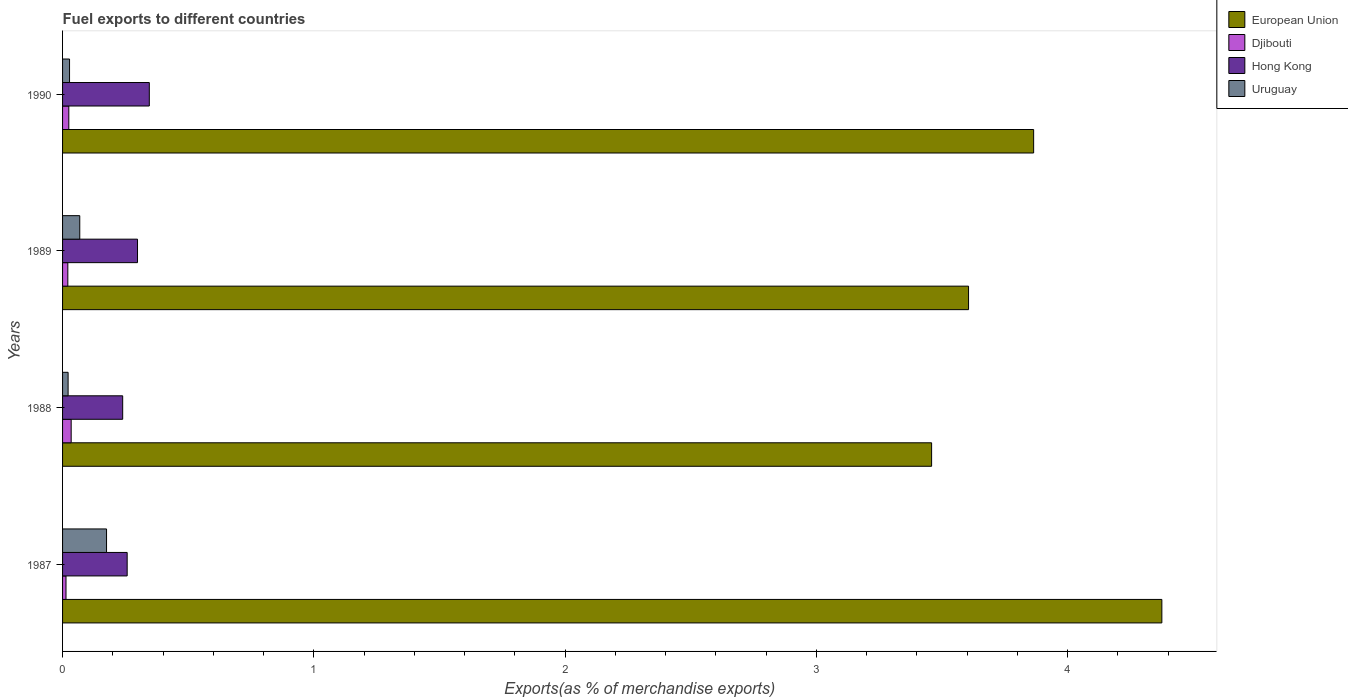How many different coloured bars are there?
Give a very brief answer. 4. Are the number of bars per tick equal to the number of legend labels?
Your answer should be very brief. Yes. Are the number of bars on each tick of the Y-axis equal?
Keep it short and to the point. Yes. How many bars are there on the 2nd tick from the top?
Provide a succinct answer. 4. What is the label of the 1st group of bars from the top?
Make the answer very short. 1990. In how many cases, is the number of bars for a given year not equal to the number of legend labels?
Your response must be concise. 0. What is the percentage of exports to different countries in Djibouti in 1987?
Offer a terse response. 0.01. Across all years, what is the maximum percentage of exports to different countries in Hong Kong?
Offer a very short reply. 0.35. Across all years, what is the minimum percentage of exports to different countries in European Union?
Offer a very short reply. 3.46. What is the total percentage of exports to different countries in Djibouti in the graph?
Provide a short and direct response. 0.09. What is the difference between the percentage of exports to different countries in European Union in 1987 and that in 1989?
Provide a short and direct response. 0.77. What is the difference between the percentage of exports to different countries in European Union in 1988 and the percentage of exports to different countries in Hong Kong in 1989?
Keep it short and to the point. 3.16. What is the average percentage of exports to different countries in European Union per year?
Give a very brief answer. 3.83. In the year 1987, what is the difference between the percentage of exports to different countries in Uruguay and percentage of exports to different countries in Hong Kong?
Provide a short and direct response. -0.08. In how many years, is the percentage of exports to different countries in European Union greater than 1.4 %?
Provide a succinct answer. 4. What is the ratio of the percentage of exports to different countries in Hong Kong in 1987 to that in 1988?
Provide a short and direct response. 1.07. What is the difference between the highest and the second highest percentage of exports to different countries in Djibouti?
Ensure brevity in your answer.  0.01. What is the difference between the highest and the lowest percentage of exports to different countries in Hong Kong?
Make the answer very short. 0.11. In how many years, is the percentage of exports to different countries in European Union greater than the average percentage of exports to different countries in European Union taken over all years?
Offer a terse response. 2. Is the sum of the percentage of exports to different countries in Djibouti in 1988 and 1989 greater than the maximum percentage of exports to different countries in Uruguay across all years?
Offer a terse response. No. Is it the case that in every year, the sum of the percentage of exports to different countries in Djibouti and percentage of exports to different countries in Uruguay is greater than the sum of percentage of exports to different countries in Hong Kong and percentage of exports to different countries in European Union?
Ensure brevity in your answer.  No. What does the 3rd bar from the bottom in 1987 represents?
Offer a terse response. Hong Kong. Is it the case that in every year, the sum of the percentage of exports to different countries in Uruguay and percentage of exports to different countries in Djibouti is greater than the percentage of exports to different countries in European Union?
Offer a terse response. No. How many years are there in the graph?
Make the answer very short. 4. Does the graph contain grids?
Ensure brevity in your answer.  No. How many legend labels are there?
Provide a succinct answer. 4. What is the title of the graph?
Your answer should be very brief. Fuel exports to different countries. Does "Low & middle income" appear as one of the legend labels in the graph?
Offer a very short reply. No. What is the label or title of the X-axis?
Offer a terse response. Exports(as % of merchandise exports). What is the Exports(as % of merchandise exports) of European Union in 1987?
Make the answer very short. 4.38. What is the Exports(as % of merchandise exports) of Djibouti in 1987?
Offer a very short reply. 0.01. What is the Exports(as % of merchandise exports) in Hong Kong in 1987?
Ensure brevity in your answer.  0.26. What is the Exports(as % of merchandise exports) in Uruguay in 1987?
Offer a terse response. 0.18. What is the Exports(as % of merchandise exports) in European Union in 1988?
Offer a terse response. 3.46. What is the Exports(as % of merchandise exports) in Djibouti in 1988?
Provide a succinct answer. 0.03. What is the Exports(as % of merchandise exports) in Hong Kong in 1988?
Your response must be concise. 0.24. What is the Exports(as % of merchandise exports) in Uruguay in 1988?
Your answer should be very brief. 0.02. What is the Exports(as % of merchandise exports) of European Union in 1989?
Ensure brevity in your answer.  3.61. What is the Exports(as % of merchandise exports) in Djibouti in 1989?
Provide a succinct answer. 0.02. What is the Exports(as % of merchandise exports) in Hong Kong in 1989?
Provide a succinct answer. 0.3. What is the Exports(as % of merchandise exports) in Uruguay in 1989?
Your answer should be compact. 0.07. What is the Exports(as % of merchandise exports) of European Union in 1990?
Offer a terse response. 3.87. What is the Exports(as % of merchandise exports) of Djibouti in 1990?
Give a very brief answer. 0.02. What is the Exports(as % of merchandise exports) of Hong Kong in 1990?
Provide a succinct answer. 0.35. What is the Exports(as % of merchandise exports) of Uruguay in 1990?
Make the answer very short. 0.03. Across all years, what is the maximum Exports(as % of merchandise exports) of European Union?
Provide a short and direct response. 4.38. Across all years, what is the maximum Exports(as % of merchandise exports) in Djibouti?
Keep it short and to the point. 0.03. Across all years, what is the maximum Exports(as % of merchandise exports) of Hong Kong?
Keep it short and to the point. 0.35. Across all years, what is the maximum Exports(as % of merchandise exports) in Uruguay?
Keep it short and to the point. 0.18. Across all years, what is the minimum Exports(as % of merchandise exports) of European Union?
Give a very brief answer. 3.46. Across all years, what is the minimum Exports(as % of merchandise exports) in Djibouti?
Give a very brief answer. 0.01. Across all years, what is the minimum Exports(as % of merchandise exports) of Hong Kong?
Your answer should be compact. 0.24. Across all years, what is the minimum Exports(as % of merchandise exports) of Uruguay?
Make the answer very short. 0.02. What is the total Exports(as % of merchandise exports) in European Union in the graph?
Your response must be concise. 15.31. What is the total Exports(as % of merchandise exports) in Djibouti in the graph?
Your answer should be compact. 0.09. What is the total Exports(as % of merchandise exports) of Hong Kong in the graph?
Your response must be concise. 1.14. What is the total Exports(as % of merchandise exports) in Uruguay in the graph?
Keep it short and to the point. 0.29. What is the difference between the Exports(as % of merchandise exports) in European Union in 1987 and that in 1988?
Your answer should be very brief. 0.92. What is the difference between the Exports(as % of merchandise exports) in Djibouti in 1987 and that in 1988?
Give a very brief answer. -0.02. What is the difference between the Exports(as % of merchandise exports) of Hong Kong in 1987 and that in 1988?
Give a very brief answer. 0.02. What is the difference between the Exports(as % of merchandise exports) of Uruguay in 1987 and that in 1988?
Keep it short and to the point. 0.15. What is the difference between the Exports(as % of merchandise exports) in European Union in 1987 and that in 1989?
Your answer should be very brief. 0.77. What is the difference between the Exports(as % of merchandise exports) in Djibouti in 1987 and that in 1989?
Keep it short and to the point. -0.01. What is the difference between the Exports(as % of merchandise exports) of Hong Kong in 1987 and that in 1989?
Your response must be concise. -0.04. What is the difference between the Exports(as % of merchandise exports) of Uruguay in 1987 and that in 1989?
Ensure brevity in your answer.  0.11. What is the difference between the Exports(as % of merchandise exports) in European Union in 1987 and that in 1990?
Your response must be concise. 0.51. What is the difference between the Exports(as % of merchandise exports) of Djibouti in 1987 and that in 1990?
Provide a short and direct response. -0.01. What is the difference between the Exports(as % of merchandise exports) of Hong Kong in 1987 and that in 1990?
Keep it short and to the point. -0.09. What is the difference between the Exports(as % of merchandise exports) in Uruguay in 1987 and that in 1990?
Offer a very short reply. 0.15. What is the difference between the Exports(as % of merchandise exports) in European Union in 1988 and that in 1989?
Your response must be concise. -0.15. What is the difference between the Exports(as % of merchandise exports) in Djibouti in 1988 and that in 1989?
Offer a very short reply. 0.01. What is the difference between the Exports(as % of merchandise exports) in Hong Kong in 1988 and that in 1989?
Provide a short and direct response. -0.06. What is the difference between the Exports(as % of merchandise exports) in Uruguay in 1988 and that in 1989?
Keep it short and to the point. -0.05. What is the difference between the Exports(as % of merchandise exports) in European Union in 1988 and that in 1990?
Offer a terse response. -0.41. What is the difference between the Exports(as % of merchandise exports) of Djibouti in 1988 and that in 1990?
Offer a very short reply. 0.01. What is the difference between the Exports(as % of merchandise exports) of Hong Kong in 1988 and that in 1990?
Give a very brief answer. -0.11. What is the difference between the Exports(as % of merchandise exports) of Uruguay in 1988 and that in 1990?
Offer a very short reply. -0.01. What is the difference between the Exports(as % of merchandise exports) of European Union in 1989 and that in 1990?
Your answer should be compact. -0.26. What is the difference between the Exports(as % of merchandise exports) in Djibouti in 1989 and that in 1990?
Ensure brevity in your answer.  -0. What is the difference between the Exports(as % of merchandise exports) in Hong Kong in 1989 and that in 1990?
Provide a short and direct response. -0.05. What is the difference between the Exports(as % of merchandise exports) in Uruguay in 1989 and that in 1990?
Offer a terse response. 0.04. What is the difference between the Exports(as % of merchandise exports) of European Union in 1987 and the Exports(as % of merchandise exports) of Djibouti in 1988?
Keep it short and to the point. 4.34. What is the difference between the Exports(as % of merchandise exports) in European Union in 1987 and the Exports(as % of merchandise exports) in Hong Kong in 1988?
Provide a succinct answer. 4.14. What is the difference between the Exports(as % of merchandise exports) in European Union in 1987 and the Exports(as % of merchandise exports) in Uruguay in 1988?
Your response must be concise. 4.35. What is the difference between the Exports(as % of merchandise exports) in Djibouti in 1987 and the Exports(as % of merchandise exports) in Hong Kong in 1988?
Provide a succinct answer. -0.23. What is the difference between the Exports(as % of merchandise exports) of Djibouti in 1987 and the Exports(as % of merchandise exports) of Uruguay in 1988?
Provide a succinct answer. -0.01. What is the difference between the Exports(as % of merchandise exports) of Hong Kong in 1987 and the Exports(as % of merchandise exports) of Uruguay in 1988?
Offer a terse response. 0.24. What is the difference between the Exports(as % of merchandise exports) in European Union in 1987 and the Exports(as % of merchandise exports) in Djibouti in 1989?
Offer a terse response. 4.35. What is the difference between the Exports(as % of merchandise exports) in European Union in 1987 and the Exports(as % of merchandise exports) in Hong Kong in 1989?
Offer a terse response. 4.08. What is the difference between the Exports(as % of merchandise exports) of European Union in 1987 and the Exports(as % of merchandise exports) of Uruguay in 1989?
Your answer should be compact. 4.31. What is the difference between the Exports(as % of merchandise exports) of Djibouti in 1987 and the Exports(as % of merchandise exports) of Hong Kong in 1989?
Your answer should be compact. -0.28. What is the difference between the Exports(as % of merchandise exports) of Djibouti in 1987 and the Exports(as % of merchandise exports) of Uruguay in 1989?
Make the answer very short. -0.05. What is the difference between the Exports(as % of merchandise exports) of Hong Kong in 1987 and the Exports(as % of merchandise exports) of Uruguay in 1989?
Give a very brief answer. 0.19. What is the difference between the Exports(as % of merchandise exports) of European Union in 1987 and the Exports(as % of merchandise exports) of Djibouti in 1990?
Ensure brevity in your answer.  4.35. What is the difference between the Exports(as % of merchandise exports) of European Union in 1987 and the Exports(as % of merchandise exports) of Hong Kong in 1990?
Provide a succinct answer. 4.03. What is the difference between the Exports(as % of merchandise exports) of European Union in 1987 and the Exports(as % of merchandise exports) of Uruguay in 1990?
Give a very brief answer. 4.35. What is the difference between the Exports(as % of merchandise exports) in Djibouti in 1987 and the Exports(as % of merchandise exports) in Hong Kong in 1990?
Provide a succinct answer. -0.33. What is the difference between the Exports(as % of merchandise exports) of Djibouti in 1987 and the Exports(as % of merchandise exports) of Uruguay in 1990?
Provide a succinct answer. -0.01. What is the difference between the Exports(as % of merchandise exports) of Hong Kong in 1987 and the Exports(as % of merchandise exports) of Uruguay in 1990?
Offer a terse response. 0.23. What is the difference between the Exports(as % of merchandise exports) of European Union in 1988 and the Exports(as % of merchandise exports) of Djibouti in 1989?
Make the answer very short. 3.44. What is the difference between the Exports(as % of merchandise exports) in European Union in 1988 and the Exports(as % of merchandise exports) in Hong Kong in 1989?
Your response must be concise. 3.16. What is the difference between the Exports(as % of merchandise exports) of European Union in 1988 and the Exports(as % of merchandise exports) of Uruguay in 1989?
Your answer should be compact. 3.39. What is the difference between the Exports(as % of merchandise exports) in Djibouti in 1988 and the Exports(as % of merchandise exports) in Hong Kong in 1989?
Keep it short and to the point. -0.26. What is the difference between the Exports(as % of merchandise exports) in Djibouti in 1988 and the Exports(as % of merchandise exports) in Uruguay in 1989?
Ensure brevity in your answer.  -0.03. What is the difference between the Exports(as % of merchandise exports) in Hong Kong in 1988 and the Exports(as % of merchandise exports) in Uruguay in 1989?
Make the answer very short. 0.17. What is the difference between the Exports(as % of merchandise exports) in European Union in 1988 and the Exports(as % of merchandise exports) in Djibouti in 1990?
Provide a short and direct response. 3.43. What is the difference between the Exports(as % of merchandise exports) of European Union in 1988 and the Exports(as % of merchandise exports) of Hong Kong in 1990?
Give a very brief answer. 3.11. What is the difference between the Exports(as % of merchandise exports) in European Union in 1988 and the Exports(as % of merchandise exports) in Uruguay in 1990?
Offer a very short reply. 3.43. What is the difference between the Exports(as % of merchandise exports) of Djibouti in 1988 and the Exports(as % of merchandise exports) of Hong Kong in 1990?
Keep it short and to the point. -0.31. What is the difference between the Exports(as % of merchandise exports) in Djibouti in 1988 and the Exports(as % of merchandise exports) in Uruguay in 1990?
Provide a succinct answer. 0.01. What is the difference between the Exports(as % of merchandise exports) of Hong Kong in 1988 and the Exports(as % of merchandise exports) of Uruguay in 1990?
Your answer should be very brief. 0.21. What is the difference between the Exports(as % of merchandise exports) in European Union in 1989 and the Exports(as % of merchandise exports) in Djibouti in 1990?
Provide a succinct answer. 3.58. What is the difference between the Exports(as % of merchandise exports) of European Union in 1989 and the Exports(as % of merchandise exports) of Hong Kong in 1990?
Offer a very short reply. 3.26. What is the difference between the Exports(as % of merchandise exports) in European Union in 1989 and the Exports(as % of merchandise exports) in Uruguay in 1990?
Offer a very short reply. 3.58. What is the difference between the Exports(as % of merchandise exports) in Djibouti in 1989 and the Exports(as % of merchandise exports) in Hong Kong in 1990?
Give a very brief answer. -0.32. What is the difference between the Exports(as % of merchandise exports) in Djibouti in 1989 and the Exports(as % of merchandise exports) in Uruguay in 1990?
Your response must be concise. -0.01. What is the difference between the Exports(as % of merchandise exports) in Hong Kong in 1989 and the Exports(as % of merchandise exports) in Uruguay in 1990?
Provide a short and direct response. 0.27. What is the average Exports(as % of merchandise exports) in European Union per year?
Make the answer very short. 3.83. What is the average Exports(as % of merchandise exports) of Djibouti per year?
Your response must be concise. 0.02. What is the average Exports(as % of merchandise exports) in Hong Kong per year?
Make the answer very short. 0.28. What is the average Exports(as % of merchandise exports) in Uruguay per year?
Your answer should be very brief. 0.07. In the year 1987, what is the difference between the Exports(as % of merchandise exports) in European Union and Exports(as % of merchandise exports) in Djibouti?
Make the answer very short. 4.36. In the year 1987, what is the difference between the Exports(as % of merchandise exports) of European Union and Exports(as % of merchandise exports) of Hong Kong?
Provide a short and direct response. 4.12. In the year 1987, what is the difference between the Exports(as % of merchandise exports) in European Union and Exports(as % of merchandise exports) in Uruguay?
Keep it short and to the point. 4.2. In the year 1987, what is the difference between the Exports(as % of merchandise exports) in Djibouti and Exports(as % of merchandise exports) in Hong Kong?
Your answer should be compact. -0.24. In the year 1987, what is the difference between the Exports(as % of merchandise exports) of Djibouti and Exports(as % of merchandise exports) of Uruguay?
Provide a succinct answer. -0.16. In the year 1987, what is the difference between the Exports(as % of merchandise exports) of Hong Kong and Exports(as % of merchandise exports) of Uruguay?
Your response must be concise. 0.08. In the year 1988, what is the difference between the Exports(as % of merchandise exports) in European Union and Exports(as % of merchandise exports) in Djibouti?
Give a very brief answer. 3.42. In the year 1988, what is the difference between the Exports(as % of merchandise exports) in European Union and Exports(as % of merchandise exports) in Hong Kong?
Make the answer very short. 3.22. In the year 1988, what is the difference between the Exports(as % of merchandise exports) in European Union and Exports(as % of merchandise exports) in Uruguay?
Ensure brevity in your answer.  3.44. In the year 1988, what is the difference between the Exports(as % of merchandise exports) of Djibouti and Exports(as % of merchandise exports) of Hong Kong?
Offer a very short reply. -0.21. In the year 1988, what is the difference between the Exports(as % of merchandise exports) in Djibouti and Exports(as % of merchandise exports) in Uruguay?
Offer a very short reply. 0.01. In the year 1988, what is the difference between the Exports(as % of merchandise exports) of Hong Kong and Exports(as % of merchandise exports) of Uruguay?
Your response must be concise. 0.22. In the year 1989, what is the difference between the Exports(as % of merchandise exports) of European Union and Exports(as % of merchandise exports) of Djibouti?
Keep it short and to the point. 3.59. In the year 1989, what is the difference between the Exports(as % of merchandise exports) of European Union and Exports(as % of merchandise exports) of Hong Kong?
Your response must be concise. 3.31. In the year 1989, what is the difference between the Exports(as % of merchandise exports) in European Union and Exports(as % of merchandise exports) in Uruguay?
Your answer should be very brief. 3.54. In the year 1989, what is the difference between the Exports(as % of merchandise exports) in Djibouti and Exports(as % of merchandise exports) in Hong Kong?
Offer a terse response. -0.28. In the year 1989, what is the difference between the Exports(as % of merchandise exports) of Djibouti and Exports(as % of merchandise exports) of Uruguay?
Ensure brevity in your answer.  -0.05. In the year 1989, what is the difference between the Exports(as % of merchandise exports) in Hong Kong and Exports(as % of merchandise exports) in Uruguay?
Keep it short and to the point. 0.23. In the year 1990, what is the difference between the Exports(as % of merchandise exports) of European Union and Exports(as % of merchandise exports) of Djibouti?
Ensure brevity in your answer.  3.84. In the year 1990, what is the difference between the Exports(as % of merchandise exports) in European Union and Exports(as % of merchandise exports) in Hong Kong?
Offer a terse response. 3.52. In the year 1990, what is the difference between the Exports(as % of merchandise exports) in European Union and Exports(as % of merchandise exports) in Uruguay?
Provide a short and direct response. 3.84. In the year 1990, what is the difference between the Exports(as % of merchandise exports) in Djibouti and Exports(as % of merchandise exports) in Hong Kong?
Offer a very short reply. -0.32. In the year 1990, what is the difference between the Exports(as % of merchandise exports) of Djibouti and Exports(as % of merchandise exports) of Uruguay?
Keep it short and to the point. -0. In the year 1990, what is the difference between the Exports(as % of merchandise exports) of Hong Kong and Exports(as % of merchandise exports) of Uruguay?
Keep it short and to the point. 0.32. What is the ratio of the Exports(as % of merchandise exports) of European Union in 1987 to that in 1988?
Provide a succinct answer. 1.26. What is the ratio of the Exports(as % of merchandise exports) in Djibouti in 1987 to that in 1988?
Offer a terse response. 0.4. What is the ratio of the Exports(as % of merchandise exports) in Hong Kong in 1987 to that in 1988?
Offer a very short reply. 1.07. What is the ratio of the Exports(as % of merchandise exports) of Uruguay in 1987 to that in 1988?
Ensure brevity in your answer.  7.94. What is the ratio of the Exports(as % of merchandise exports) of European Union in 1987 to that in 1989?
Ensure brevity in your answer.  1.21. What is the ratio of the Exports(as % of merchandise exports) of Djibouti in 1987 to that in 1989?
Keep it short and to the point. 0.65. What is the ratio of the Exports(as % of merchandise exports) in Hong Kong in 1987 to that in 1989?
Your answer should be compact. 0.86. What is the ratio of the Exports(as % of merchandise exports) of Uruguay in 1987 to that in 1989?
Your answer should be compact. 2.56. What is the ratio of the Exports(as % of merchandise exports) in European Union in 1987 to that in 1990?
Ensure brevity in your answer.  1.13. What is the ratio of the Exports(as % of merchandise exports) of Djibouti in 1987 to that in 1990?
Offer a very short reply. 0.55. What is the ratio of the Exports(as % of merchandise exports) in Hong Kong in 1987 to that in 1990?
Provide a succinct answer. 0.74. What is the ratio of the Exports(as % of merchandise exports) of Uruguay in 1987 to that in 1990?
Provide a succinct answer. 6.29. What is the ratio of the Exports(as % of merchandise exports) in European Union in 1988 to that in 1989?
Ensure brevity in your answer.  0.96. What is the ratio of the Exports(as % of merchandise exports) in Djibouti in 1988 to that in 1989?
Offer a terse response. 1.64. What is the ratio of the Exports(as % of merchandise exports) of Hong Kong in 1988 to that in 1989?
Make the answer very short. 0.8. What is the ratio of the Exports(as % of merchandise exports) of Uruguay in 1988 to that in 1989?
Ensure brevity in your answer.  0.32. What is the ratio of the Exports(as % of merchandise exports) of European Union in 1988 to that in 1990?
Give a very brief answer. 0.89. What is the ratio of the Exports(as % of merchandise exports) in Djibouti in 1988 to that in 1990?
Your answer should be very brief. 1.38. What is the ratio of the Exports(as % of merchandise exports) of Hong Kong in 1988 to that in 1990?
Provide a short and direct response. 0.69. What is the ratio of the Exports(as % of merchandise exports) in Uruguay in 1988 to that in 1990?
Keep it short and to the point. 0.79. What is the ratio of the Exports(as % of merchandise exports) of European Union in 1989 to that in 1990?
Provide a short and direct response. 0.93. What is the ratio of the Exports(as % of merchandise exports) of Djibouti in 1989 to that in 1990?
Make the answer very short. 0.84. What is the ratio of the Exports(as % of merchandise exports) in Hong Kong in 1989 to that in 1990?
Ensure brevity in your answer.  0.86. What is the ratio of the Exports(as % of merchandise exports) of Uruguay in 1989 to that in 1990?
Your answer should be compact. 2.46. What is the difference between the highest and the second highest Exports(as % of merchandise exports) in European Union?
Offer a terse response. 0.51. What is the difference between the highest and the second highest Exports(as % of merchandise exports) in Djibouti?
Make the answer very short. 0.01. What is the difference between the highest and the second highest Exports(as % of merchandise exports) of Hong Kong?
Give a very brief answer. 0.05. What is the difference between the highest and the second highest Exports(as % of merchandise exports) in Uruguay?
Offer a terse response. 0.11. What is the difference between the highest and the lowest Exports(as % of merchandise exports) of European Union?
Offer a very short reply. 0.92. What is the difference between the highest and the lowest Exports(as % of merchandise exports) in Djibouti?
Make the answer very short. 0.02. What is the difference between the highest and the lowest Exports(as % of merchandise exports) of Hong Kong?
Provide a succinct answer. 0.11. What is the difference between the highest and the lowest Exports(as % of merchandise exports) in Uruguay?
Your answer should be compact. 0.15. 